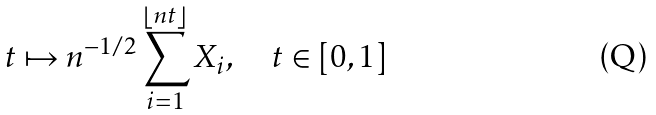Convert formula to latex. <formula><loc_0><loc_0><loc_500><loc_500>t \mapsto n ^ { - 1 / 2 } \sum _ { i = 1 } ^ { \lfloor n t \rfloor } X _ { i } , \quad t \in [ 0 , 1 ]</formula> 